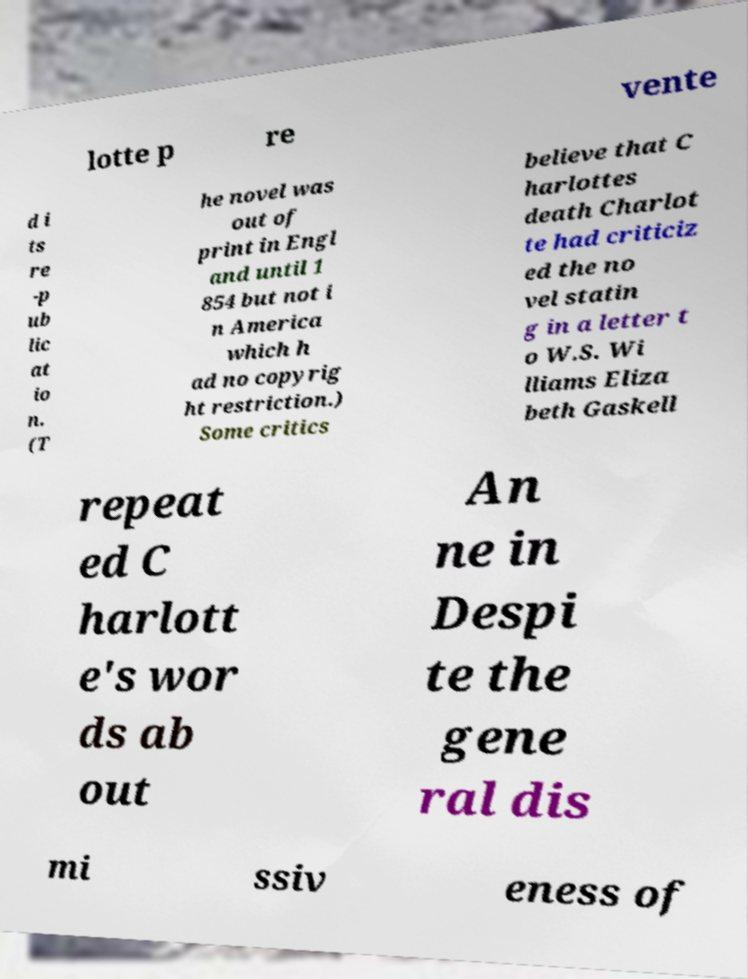Could you extract and type out the text from this image? lotte p re vente d i ts re -p ub lic at io n. (T he novel was out of print in Engl and until 1 854 but not i n America which h ad no copyrig ht restriction.) Some critics believe that C harlottes death Charlot te had criticiz ed the no vel statin g in a letter t o W.S. Wi lliams Eliza beth Gaskell repeat ed C harlott e's wor ds ab out An ne in Despi te the gene ral dis mi ssiv eness of 